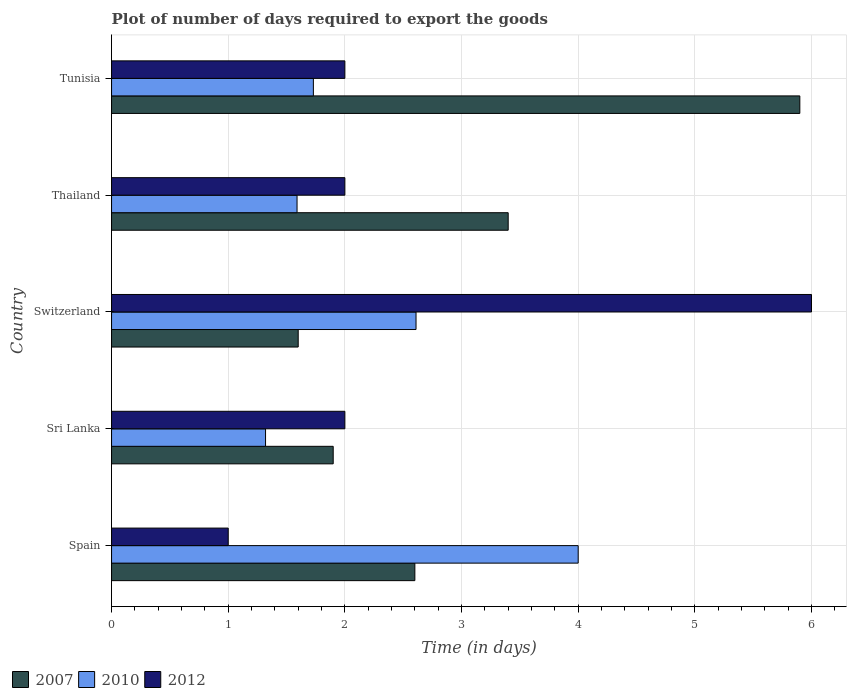How many bars are there on the 2nd tick from the top?
Offer a terse response. 3. What is the label of the 3rd group of bars from the top?
Provide a succinct answer. Switzerland. In how many cases, is the number of bars for a given country not equal to the number of legend labels?
Your answer should be compact. 0. Across all countries, what is the maximum time required to export goods in 2012?
Provide a short and direct response. 6. Across all countries, what is the minimum time required to export goods in 2007?
Your response must be concise. 1.6. In which country was the time required to export goods in 2010 minimum?
Ensure brevity in your answer.  Sri Lanka. What is the difference between the time required to export goods in 2012 in Thailand and the time required to export goods in 2007 in Switzerland?
Your response must be concise. 0.4. What is the average time required to export goods in 2007 per country?
Offer a very short reply. 3.08. What is the difference between the time required to export goods in 2007 and time required to export goods in 2012 in Thailand?
Provide a short and direct response. 1.4. What is the ratio of the time required to export goods in 2007 in Spain to that in Sri Lanka?
Keep it short and to the point. 1.37. What is the difference between the highest and the second highest time required to export goods in 2010?
Your response must be concise. 1.39. What is the difference between the highest and the lowest time required to export goods in 2010?
Keep it short and to the point. 2.68. In how many countries, is the time required to export goods in 2010 greater than the average time required to export goods in 2010 taken over all countries?
Provide a succinct answer. 2. What does the 1st bar from the top in Switzerland represents?
Offer a very short reply. 2012. Where does the legend appear in the graph?
Provide a short and direct response. Bottom left. How are the legend labels stacked?
Give a very brief answer. Horizontal. What is the title of the graph?
Your answer should be compact. Plot of number of days required to export the goods. Does "1988" appear as one of the legend labels in the graph?
Offer a very short reply. No. What is the label or title of the X-axis?
Give a very brief answer. Time (in days). What is the Time (in days) in 2010 in Spain?
Provide a short and direct response. 4. What is the Time (in days) in 2007 in Sri Lanka?
Offer a very short reply. 1.9. What is the Time (in days) of 2010 in Sri Lanka?
Provide a short and direct response. 1.32. What is the Time (in days) of 2010 in Switzerland?
Your response must be concise. 2.61. What is the Time (in days) of 2012 in Switzerland?
Your answer should be compact. 6. What is the Time (in days) of 2010 in Thailand?
Your response must be concise. 1.59. What is the Time (in days) in 2010 in Tunisia?
Make the answer very short. 1.73. Across all countries, what is the maximum Time (in days) in 2012?
Provide a succinct answer. 6. Across all countries, what is the minimum Time (in days) of 2007?
Offer a terse response. 1.6. Across all countries, what is the minimum Time (in days) of 2010?
Your response must be concise. 1.32. What is the total Time (in days) in 2010 in the graph?
Give a very brief answer. 11.25. What is the total Time (in days) of 2012 in the graph?
Give a very brief answer. 13. What is the difference between the Time (in days) in 2010 in Spain and that in Sri Lanka?
Ensure brevity in your answer.  2.68. What is the difference between the Time (in days) in 2010 in Spain and that in Switzerland?
Your answer should be very brief. 1.39. What is the difference between the Time (in days) in 2012 in Spain and that in Switzerland?
Your answer should be compact. -5. What is the difference between the Time (in days) in 2007 in Spain and that in Thailand?
Make the answer very short. -0.8. What is the difference between the Time (in days) of 2010 in Spain and that in Thailand?
Provide a succinct answer. 2.41. What is the difference between the Time (in days) of 2012 in Spain and that in Thailand?
Offer a very short reply. -1. What is the difference between the Time (in days) of 2010 in Spain and that in Tunisia?
Offer a very short reply. 2.27. What is the difference between the Time (in days) of 2010 in Sri Lanka and that in Switzerland?
Offer a terse response. -1.29. What is the difference between the Time (in days) in 2012 in Sri Lanka and that in Switzerland?
Offer a terse response. -4. What is the difference between the Time (in days) of 2010 in Sri Lanka and that in Thailand?
Offer a very short reply. -0.27. What is the difference between the Time (in days) in 2007 in Sri Lanka and that in Tunisia?
Give a very brief answer. -4. What is the difference between the Time (in days) of 2010 in Sri Lanka and that in Tunisia?
Your response must be concise. -0.41. What is the difference between the Time (in days) of 2012 in Switzerland and that in Thailand?
Provide a succinct answer. 4. What is the difference between the Time (in days) in 2007 in Switzerland and that in Tunisia?
Your answer should be very brief. -4.3. What is the difference between the Time (in days) in 2010 in Thailand and that in Tunisia?
Keep it short and to the point. -0.14. What is the difference between the Time (in days) in 2007 in Spain and the Time (in days) in 2010 in Sri Lanka?
Give a very brief answer. 1.28. What is the difference between the Time (in days) of 2007 in Spain and the Time (in days) of 2010 in Switzerland?
Your response must be concise. -0.01. What is the difference between the Time (in days) in 2007 in Spain and the Time (in days) in 2012 in Switzerland?
Your answer should be very brief. -3.4. What is the difference between the Time (in days) in 2007 in Spain and the Time (in days) in 2010 in Thailand?
Your answer should be compact. 1.01. What is the difference between the Time (in days) in 2010 in Spain and the Time (in days) in 2012 in Thailand?
Keep it short and to the point. 2. What is the difference between the Time (in days) in 2007 in Spain and the Time (in days) in 2010 in Tunisia?
Give a very brief answer. 0.87. What is the difference between the Time (in days) of 2007 in Spain and the Time (in days) of 2012 in Tunisia?
Provide a succinct answer. 0.6. What is the difference between the Time (in days) in 2007 in Sri Lanka and the Time (in days) in 2010 in Switzerland?
Offer a very short reply. -0.71. What is the difference between the Time (in days) of 2010 in Sri Lanka and the Time (in days) of 2012 in Switzerland?
Your response must be concise. -4.68. What is the difference between the Time (in days) in 2007 in Sri Lanka and the Time (in days) in 2010 in Thailand?
Ensure brevity in your answer.  0.31. What is the difference between the Time (in days) of 2010 in Sri Lanka and the Time (in days) of 2012 in Thailand?
Provide a short and direct response. -0.68. What is the difference between the Time (in days) of 2007 in Sri Lanka and the Time (in days) of 2010 in Tunisia?
Provide a succinct answer. 0.17. What is the difference between the Time (in days) of 2007 in Sri Lanka and the Time (in days) of 2012 in Tunisia?
Offer a very short reply. -0.1. What is the difference between the Time (in days) in 2010 in Sri Lanka and the Time (in days) in 2012 in Tunisia?
Make the answer very short. -0.68. What is the difference between the Time (in days) in 2010 in Switzerland and the Time (in days) in 2012 in Thailand?
Keep it short and to the point. 0.61. What is the difference between the Time (in days) in 2007 in Switzerland and the Time (in days) in 2010 in Tunisia?
Your answer should be very brief. -0.13. What is the difference between the Time (in days) in 2007 in Switzerland and the Time (in days) in 2012 in Tunisia?
Offer a very short reply. -0.4. What is the difference between the Time (in days) of 2010 in Switzerland and the Time (in days) of 2012 in Tunisia?
Make the answer very short. 0.61. What is the difference between the Time (in days) of 2007 in Thailand and the Time (in days) of 2010 in Tunisia?
Your response must be concise. 1.67. What is the difference between the Time (in days) of 2010 in Thailand and the Time (in days) of 2012 in Tunisia?
Ensure brevity in your answer.  -0.41. What is the average Time (in days) in 2007 per country?
Keep it short and to the point. 3.08. What is the average Time (in days) in 2010 per country?
Keep it short and to the point. 2.25. What is the difference between the Time (in days) in 2007 and Time (in days) in 2010 in Spain?
Give a very brief answer. -1.4. What is the difference between the Time (in days) in 2007 and Time (in days) in 2012 in Spain?
Make the answer very short. 1.6. What is the difference between the Time (in days) of 2007 and Time (in days) of 2010 in Sri Lanka?
Keep it short and to the point. 0.58. What is the difference between the Time (in days) of 2007 and Time (in days) of 2012 in Sri Lanka?
Keep it short and to the point. -0.1. What is the difference between the Time (in days) of 2010 and Time (in days) of 2012 in Sri Lanka?
Offer a terse response. -0.68. What is the difference between the Time (in days) in 2007 and Time (in days) in 2010 in Switzerland?
Ensure brevity in your answer.  -1.01. What is the difference between the Time (in days) in 2010 and Time (in days) in 2012 in Switzerland?
Ensure brevity in your answer.  -3.39. What is the difference between the Time (in days) of 2007 and Time (in days) of 2010 in Thailand?
Your response must be concise. 1.81. What is the difference between the Time (in days) in 2010 and Time (in days) in 2012 in Thailand?
Your answer should be very brief. -0.41. What is the difference between the Time (in days) of 2007 and Time (in days) of 2010 in Tunisia?
Make the answer very short. 4.17. What is the difference between the Time (in days) of 2007 and Time (in days) of 2012 in Tunisia?
Give a very brief answer. 3.9. What is the difference between the Time (in days) in 2010 and Time (in days) in 2012 in Tunisia?
Offer a very short reply. -0.27. What is the ratio of the Time (in days) in 2007 in Spain to that in Sri Lanka?
Your response must be concise. 1.37. What is the ratio of the Time (in days) of 2010 in Spain to that in Sri Lanka?
Your answer should be compact. 3.03. What is the ratio of the Time (in days) of 2012 in Spain to that in Sri Lanka?
Ensure brevity in your answer.  0.5. What is the ratio of the Time (in days) of 2007 in Spain to that in Switzerland?
Give a very brief answer. 1.62. What is the ratio of the Time (in days) in 2010 in Spain to that in Switzerland?
Offer a terse response. 1.53. What is the ratio of the Time (in days) of 2012 in Spain to that in Switzerland?
Your answer should be very brief. 0.17. What is the ratio of the Time (in days) of 2007 in Spain to that in Thailand?
Your answer should be compact. 0.76. What is the ratio of the Time (in days) in 2010 in Spain to that in Thailand?
Offer a terse response. 2.52. What is the ratio of the Time (in days) in 2007 in Spain to that in Tunisia?
Make the answer very short. 0.44. What is the ratio of the Time (in days) of 2010 in Spain to that in Tunisia?
Offer a terse response. 2.31. What is the ratio of the Time (in days) of 2012 in Spain to that in Tunisia?
Offer a terse response. 0.5. What is the ratio of the Time (in days) of 2007 in Sri Lanka to that in Switzerland?
Keep it short and to the point. 1.19. What is the ratio of the Time (in days) of 2010 in Sri Lanka to that in Switzerland?
Offer a terse response. 0.51. What is the ratio of the Time (in days) in 2012 in Sri Lanka to that in Switzerland?
Your response must be concise. 0.33. What is the ratio of the Time (in days) in 2007 in Sri Lanka to that in Thailand?
Provide a succinct answer. 0.56. What is the ratio of the Time (in days) of 2010 in Sri Lanka to that in Thailand?
Keep it short and to the point. 0.83. What is the ratio of the Time (in days) of 2012 in Sri Lanka to that in Thailand?
Offer a very short reply. 1. What is the ratio of the Time (in days) of 2007 in Sri Lanka to that in Tunisia?
Offer a very short reply. 0.32. What is the ratio of the Time (in days) in 2010 in Sri Lanka to that in Tunisia?
Your answer should be very brief. 0.76. What is the ratio of the Time (in days) in 2012 in Sri Lanka to that in Tunisia?
Your answer should be very brief. 1. What is the ratio of the Time (in days) of 2007 in Switzerland to that in Thailand?
Your answer should be compact. 0.47. What is the ratio of the Time (in days) in 2010 in Switzerland to that in Thailand?
Your response must be concise. 1.64. What is the ratio of the Time (in days) of 2007 in Switzerland to that in Tunisia?
Offer a terse response. 0.27. What is the ratio of the Time (in days) of 2010 in Switzerland to that in Tunisia?
Your answer should be compact. 1.51. What is the ratio of the Time (in days) in 2012 in Switzerland to that in Tunisia?
Provide a succinct answer. 3. What is the ratio of the Time (in days) in 2007 in Thailand to that in Tunisia?
Offer a very short reply. 0.58. What is the ratio of the Time (in days) of 2010 in Thailand to that in Tunisia?
Offer a very short reply. 0.92. What is the difference between the highest and the second highest Time (in days) of 2010?
Offer a terse response. 1.39. What is the difference between the highest and the second highest Time (in days) in 2012?
Provide a short and direct response. 4. What is the difference between the highest and the lowest Time (in days) in 2010?
Give a very brief answer. 2.68. What is the difference between the highest and the lowest Time (in days) of 2012?
Offer a terse response. 5. 